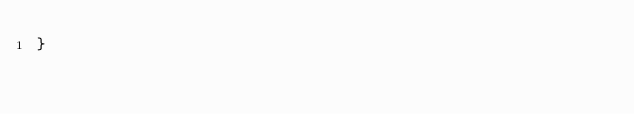Convert code to text. <code><loc_0><loc_0><loc_500><loc_500><_PHP_>}
</code> 